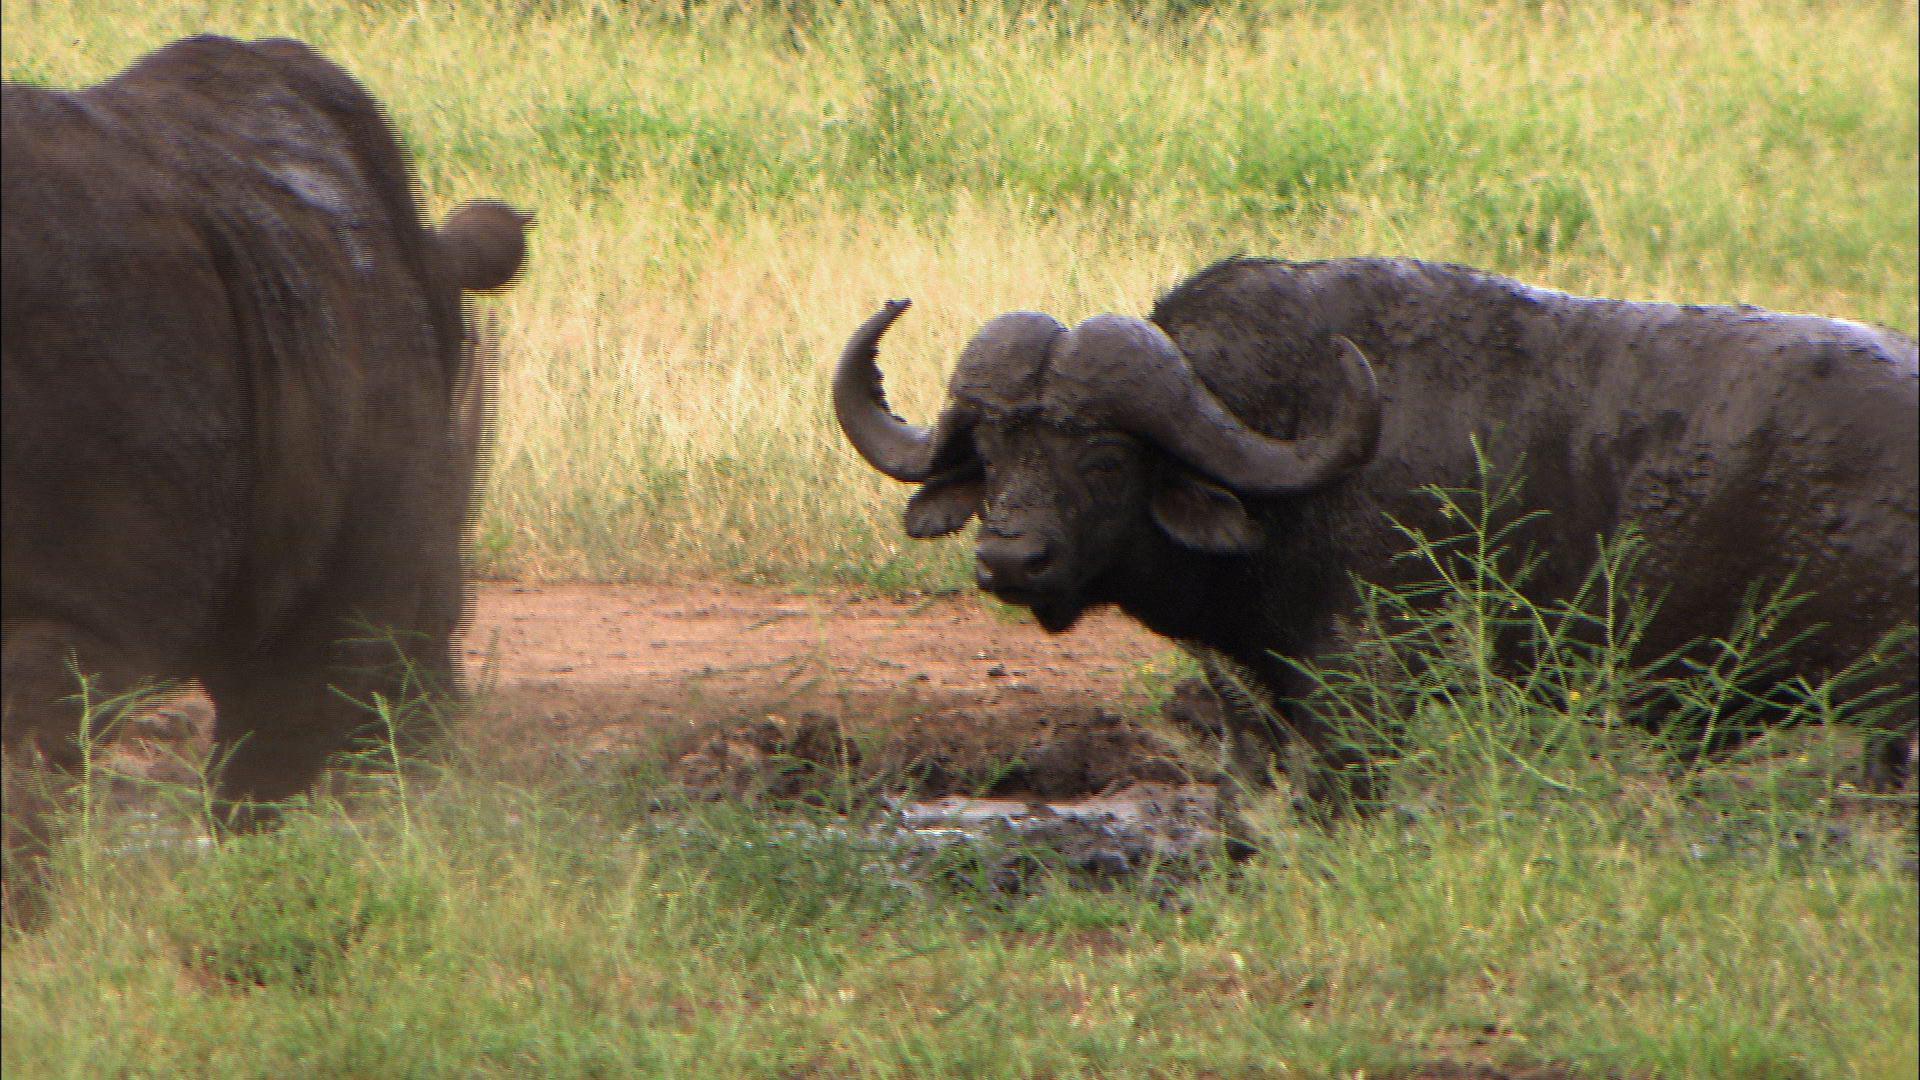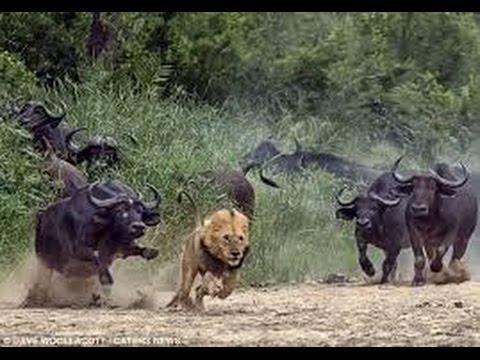The first image is the image on the left, the second image is the image on the right. Analyze the images presented: Is the assertion "There is more than one animal in the image on the right" valid? Answer yes or no. Yes. The first image is the image on the left, the second image is the image on the right. For the images shown, is this caption "One image shows at least four water buffalo." true? Answer yes or no. Yes. 